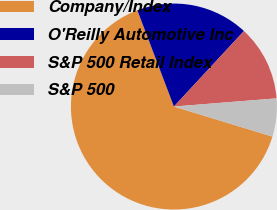<chart> <loc_0><loc_0><loc_500><loc_500><pie_chart><fcel>Company/Index<fcel>O'Reilly Automotive Inc<fcel>S&P 500 Retail Index<fcel>S&P 500<nl><fcel>64.5%<fcel>17.68%<fcel>11.83%<fcel>5.98%<nl></chart> 